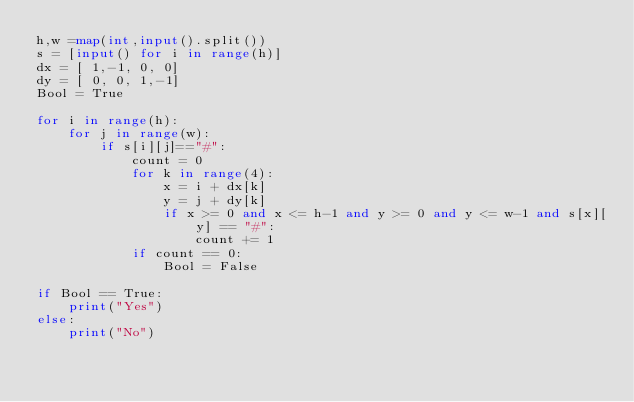Convert code to text. <code><loc_0><loc_0><loc_500><loc_500><_Python_>h,w =map(int,input().split())
s = [input() for i in range(h)]
dx = [ 1,-1, 0, 0]
dy = [ 0, 0, 1,-1]
Bool = True

for i in range(h):
    for j in range(w):
        if s[i][j]=="#":
            count = 0
            for k in range(4):
                x = i + dx[k]
                y = j + dy[k]
                if x >= 0 and x <= h-1 and y >= 0 and y <= w-1 and s[x][y] == "#":
                    count += 1
            if count == 0:
                Bool = False
                
if Bool == True:
    print("Yes")
else:
    print("No")
                
            </code> 